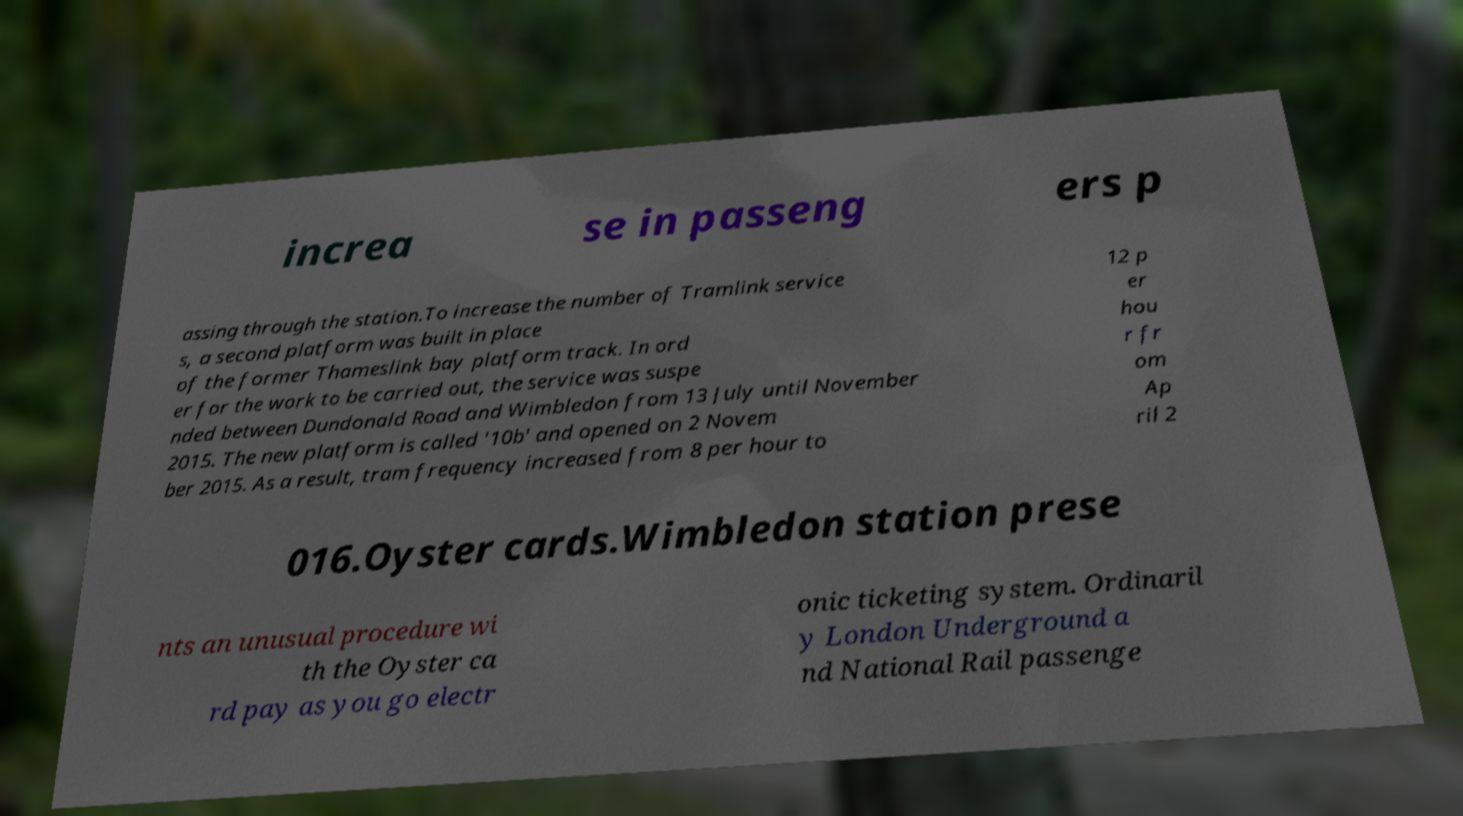Can you accurately transcribe the text from the provided image for me? increa se in passeng ers p assing through the station.To increase the number of Tramlink service s, a second platform was built in place of the former Thameslink bay platform track. In ord er for the work to be carried out, the service was suspe nded between Dundonald Road and Wimbledon from 13 July until November 2015. The new platform is called '10b' and opened on 2 Novem ber 2015. As a result, tram frequency increased from 8 per hour to 12 p er hou r fr om Ap ril 2 016.Oyster cards.Wimbledon station prese nts an unusual procedure wi th the Oyster ca rd pay as you go electr onic ticketing system. Ordinaril y London Underground a nd National Rail passenge 